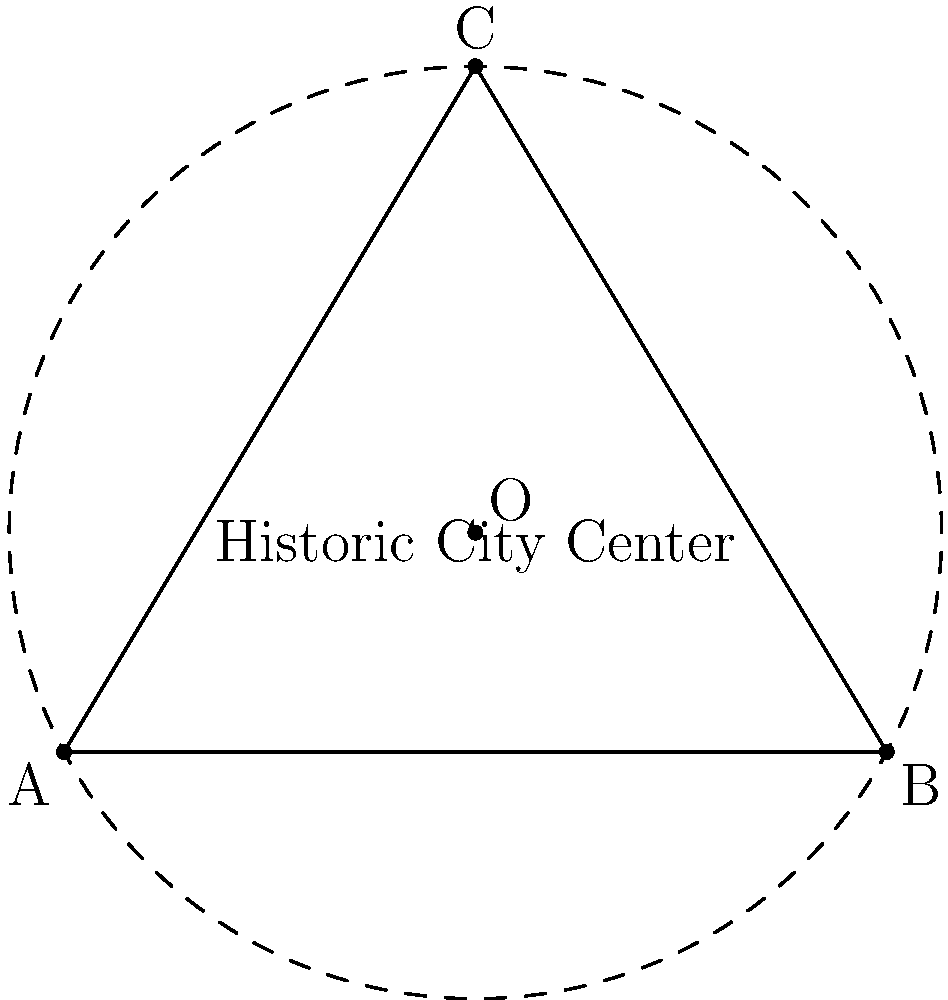In Amsterdam's historic city center, three significant landmarks form a triangle: Dam Square (A), Centraal Station (B), and the Anne Frank House (C). Their relative positions can be represented on a coordinate plane where Dam Square is at (0,0), Centraal Station at (6,0), and the Anne Frank House at (3,5). To create a circular tourist route that encompasses these landmarks, determine the center (O) and radius (r) of the circle that passes through all three points. To find the center and radius of the circle passing through these three points, we'll use the properties of the circumcenter of a triangle:

1) The circumcenter is the point where the perpendicular bisectors of the triangle's sides intersect.

2) Calculate the midpoint of side AB:
   $M_{AB} = (\frac{0+6}{2}, \frac{0+0}{2}) = (3,0)$

3) Calculate the slope of AB and its perpendicular bisector:
   $m_{AB} = 0$
   $m_{\perp AB} = \text{undefined (vertical line)}$

4) Equation of perpendicular bisector of AB: $x = 3$

5) Calculate the midpoint of side BC:
   $M_{BC} = (\frac{6+3}{2}, \frac{0+5}{2}) = (4.5, 2.5)$

6) Calculate the slope of BC and its perpendicular bisector:
   $m_{BC} = \frac{5-0}{3-6} = -\frac{5}{3}$
   $m_{\perp BC} = \frac{3}{5}$

7) Equation of perpendicular bisector of BC:
   $y - 2.5 = \frac{3}{5}(x - 4.5)$

8) Solve the system of equations to find O:
   $x = 3$
   $y - 2.5 = \frac{3}{5}(3 - 4.5) = -0.9$
   $y = 1.6$

   Therefore, $O = (3, 1.6)$

9) Calculate the radius by finding the distance from O to any of the three points:
   $r = \sqrt{(3-0)^2 + (1.6-0)^2} = \sqrt{9 + 2.56} = \sqrt{11.56} \approx 3.4$
Answer: Center: (3, 1.6), Radius: $\sqrt{11.56}$ ≈ 3.4 